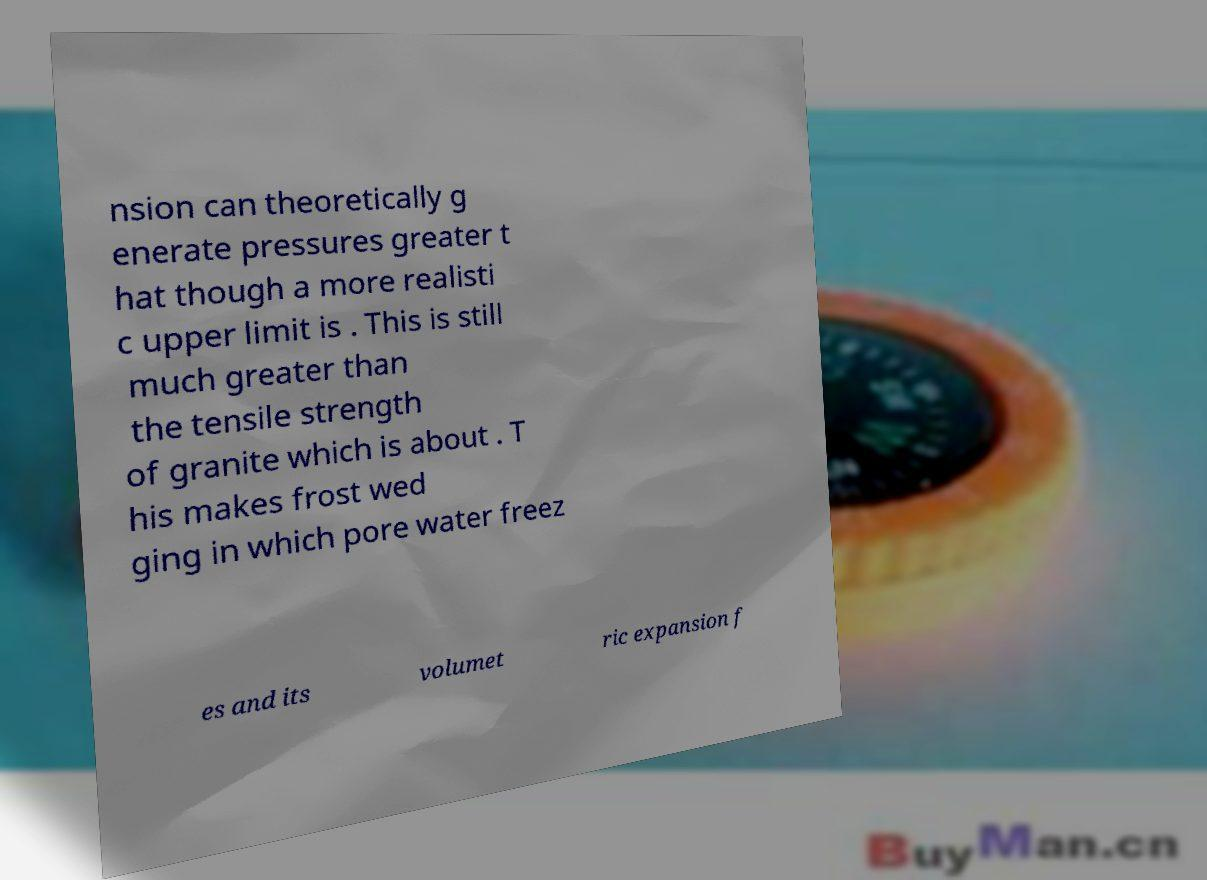Could you assist in decoding the text presented in this image and type it out clearly? nsion can theoretically g enerate pressures greater t hat though a more realisti c upper limit is . This is still much greater than the tensile strength of granite which is about . T his makes frost wed ging in which pore water freez es and its volumet ric expansion f 